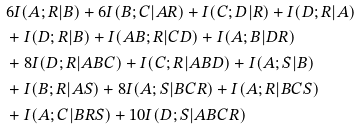Convert formula to latex. <formula><loc_0><loc_0><loc_500><loc_500>& \ \ 6 I ( A ; R | B ) + 6 I ( B ; C | A R ) + I ( C ; D | R ) + I ( D ; R | A ) \\ & \ \ + I ( D ; R | B ) + I ( A B ; R | C D ) + I ( A ; B | D R ) \\ & \ \ + 8 I ( D ; R | A B C ) + I ( C ; R | A B D ) + I ( A ; S | B ) \\ & \ \ + I ( B ; R | A S ) + 8 I ( A ; S | B C R ) + I ( A ; R | B C S ) \\ & \ \ + I ( A ; C | B R S ) + 1 0 I ( D ; S | A B C R )</formula> 